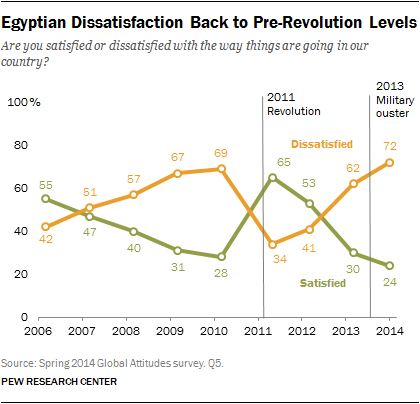Specify some key components in this picture. Eight satisfied data points are below 60%. 